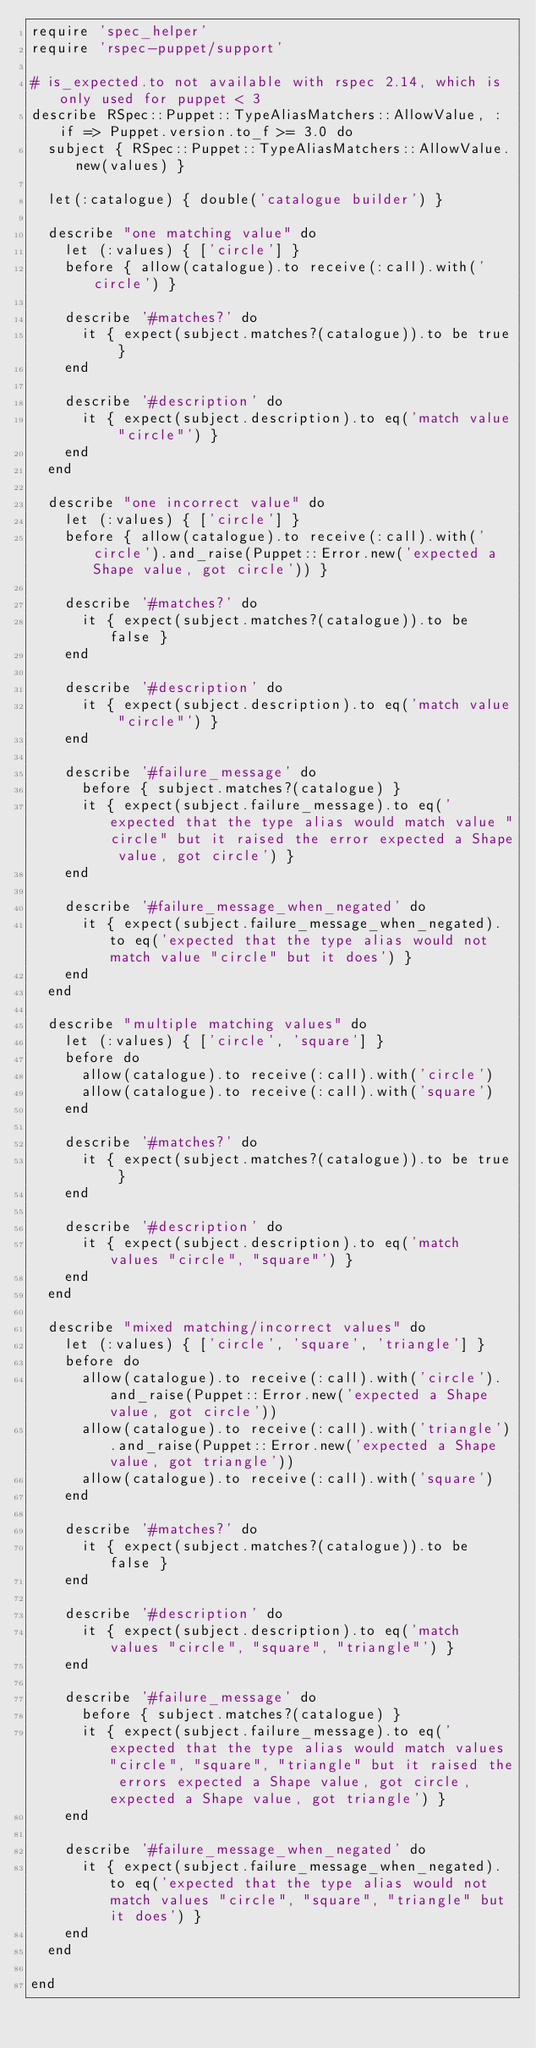<code> <loc_0><loc_0><loc_500><loc_500><_Ruby_>require 'spec_helper'
require 'rspec-puppet/support'

# is_expected.to not available with rspec 2.14, which is only used for puppet < 3
describe RSpec::Puppet::TypeAliasMatchers::AllowValue, :if => Puppet.version.to_f >= 3.0 do
  subject { RSpec::Puppet::TypeAliasMatchers::AllowValue.new(values) }

  let(:catalogue) { double('catalogue builder') }

  describe "one matching value" do
    let (:values) { ['circle'] }
    before { allow(catalogue).to receive(:call).with('circle') }

    describe '#matches?' do
      it { expect(subject.matches?(catalogue)).to be true }
    end

    describe '#description' do
      it { expect(subject.description).to eq('match value "circle"') }
    end
  end

  describe "one incorrect value" do
    let (:values) { ['circle'] }
    before { allow(catalogue).to receive(:call).with('circle').and_raise(Puppet::Error.new('expected a Shape value, got circle')) }

    describe '#matches?' do
      it { expect(subject.matches?(catalogue)).to be false }
    end

    describe '#description' do
      it { expect(subject.description).to eq('match value "circle"') }
    end

    describe '#failure_message' do
      before { subject.matches?(catalogue) }
      it { expect(subject.failure_message).to eq('expected that the type alias would match value "circle" but it raised the error expected a Shape value, got circle') }
    end

    describe '#failure_message_when_negated' do
      it { expect(subject.failure_message_when_negated).to eq('expected that the type alias would not match value "circle" but it does') }
    end
  end

  describe "multiple matching values" do
    let (:values) { ['circle', 'square'] }
    before do
      allow(catalogue).to receive(:call).with('circle')
      allow(catalogue).to receive(:call).with('square')
    end

    describe '#matches?' do
      it { expect(subject.matches?(catalogue)).to be true }
    end

    describe '#description' do
      it { expect(subject.description).to eq('match values "circle", "square"') }
    end
  end

  describe "mixed matching/incorrect values" do
    let (:values) { ['circle', 'square', 'triangle'] }
    before do
      allow(catalogue).to receive(:call).with('circle').and_raise(Puppet::Error.new('expected a Shape value, got circle'))
      allow(catalogue).to receive(:call).with('triangle').and_raise(Puppet::Error.new('expected a Shape value, got triangle'))
      allow(catalogue).to receive(:call).with('square')
    end

    describe '#matches?' do
      it { expect(subject.matches?(catalogue)).to be false }
    end

    describe '#description' do
      it { expect(subject.description).to eq('match values "circle", "square", "triangle"') }
    end

    describe '#failure_message' do
      before { subject.matches?(catalogue) }
      it { expect(subject.failure_message).to eq('expected that the type alias would match values "circle", "square", "triangle" but it raised the errors expected a Shape value, got circle, expected a Shape value, got triangle') }
    end

    describe '#failure_message_when_negated' do
      it { expect(subject.failure_message_when_negated).to eq('expected that the type alias would not match values "circle", "square", "triangle" but it does') }
    end
  end

end
</code> 